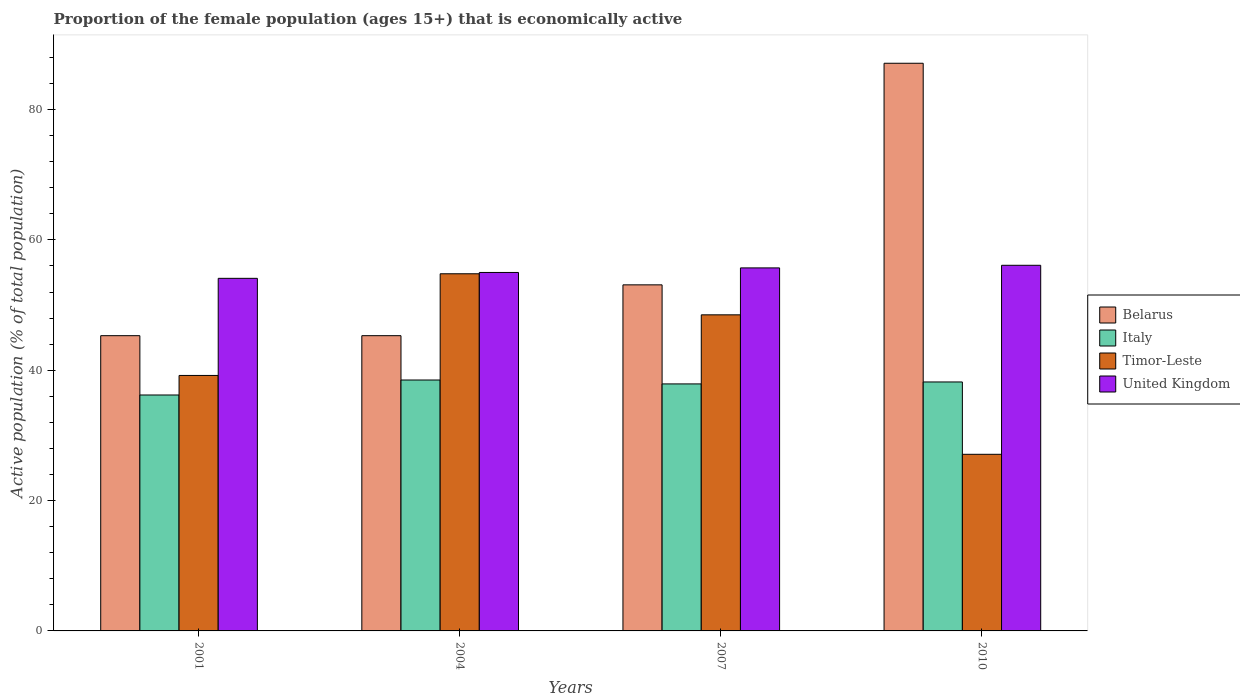Are the number of bars per tick equal to the number of legend labels?
Offer a terse response. Yes. Are the number of bars on each tick of the X-axis equal?
Your answer should be compact. Yes. How many bars are there on the 4th tick from the right?
Your answer should be compact. 4. What is the label of the 2nd group of bars from the left?
Your response must be concise. 2004. In how many cases, is the number of bars for a given year not equal to the number of legend labels?
Ensure brevity in your answer.  0. What is the proportion of the female population that is economically active in Italy in 2004?
Give a very brief answer. 38.5. Across all years, what is the maximum proportion of the female population that is economically active in Timor-Leste?
Make the answer very short. 54.8. Across all years, what is the minimum proportion of the female population that is economically active in Timor-Leste?
Offer a terse response. 27.1. In which year was the proportion of the female population that is economically active in Timor-Leste minimum?
Your answer should be very brief. 2010. What is the total proportion of the female population that is economically active in Timor-Leste in the graph?
Offer a very short reply. 169.6. What is the difference between the proportion of the female population that is economically active in Belarus in 2001 and that in 2010?
Provide a succinct answer. -41.8. What is the difference between the proportion of the female population that is economically active in Timor-Leste in 2010 and the proportion of the female population that is economically active in Italy in 2001?
Offer a very short reply. -9.1. What is the average proportion of the female population that is economically active in Timor-Leste per year?
Offer a terse response. 42.4. In the year 2010, what is the difference between the proportion of the female population that is economically active in United Kingdom and proportion of the female population that is economically active in Italy?
Your answer should be very brief. 17.9. What is the ratio of the proportion of the female population that is economically active in Belarus in 2007 to that in 2010?
Offer a terse response. 0.61. Is the proportion of the female population that is economically active in United Kingdom in 2001 less than that in 2010?
Your answer should be compact. Yes. Is the difference between the proportion of the female population that is economically active in United Kingdom in 2001 and 2007 greater than the difference between the proportion of the female population that is economically active in Italy in 2001 and 2007?
Offer a very short reply. Yes. What is the difference between the highest and the second highest proportion of the female population that is economically active in Timor-Leste?
Offer a terse response. 6.3. What is the difference between the highest and the lowest proportion of the female population that is economically active in United Kingdom?
Provide a short and direct response. 2. In how many years, is the proportion of the female population that is economically active in United Kingdom greater than the average proportion of the female population that is economically active in United Kingdom taken over all years?
Your response must be concise. 2. Is it the case that in every year, the sum of the proportion of the female population that is economically active in Italy and proportion of the female population that is economically active in United Kingdom is greater than the sum of proportion of the female population that is economically active in Belarus and proportion of the female population that is economically active in Timor-Leste?
Make the answer very short. Yes. What does the 4th bar from the left in 2010 represents?
Make the answer very short. United Kingdom. What does the 3rd bar from the right in 2010 represents?
Your answer should be compact. Italy. Is it the case that in every year, the sum of the proportion of the female population that is economically active in Timor-Leste and proportion of the female population that is economically active in Belarus is greater than the proportion of the female population that is economically active in Italy?
Provide a short and direct response. Yes. How many bars are there?
Keep it short and to the point. 16. Are all the bars in the graph horizontal?
Your answer should be compact. No. How many years are there in the graph?
Provide a short and direct response. 4. Are the values on the major ticks of Y-axis written in scientific E-notation?
Your response must be concise. No. How many legend labels are there?
Provide a succinct answer. 4. How are the legend labels stacked?
Make the answer very short. Vertical. What is the title of the graph?
Your response must be concise. Proportion of the female population (ages 15+) that is economically active. What is the label or title of the X-axis?
Provide a short and direct response. Years. What is the label or title of the Y-axis?
Provide a short and direct response. Active population (% of total population). What is the Active population (% of total population) in Belarus in 2001?
Offer a very short reply. 45.3. What is the Active population (% of total population) of Italy in 2001?
Make the answer very short. 36.2. What is the Active population (% of total population) of Timor-Leste in 2001?
Offer a terse response. 39.2. What is the Active population (% of total population) of United Kingdom in 2001?
Your answer should be compact. 54.1. What is the Active population (% of total population) in Belarus in 2004?
Offer a terse response. 45.3. What is the Active population (% of total population) in Italy in 2004?
Offer a terse response. 38.5. What is the Active population (% of total population) of Timor-Leste in 2004?
Keep it short and to the point. 54.8. What is the Active population (% of total population) in United Kingdom in 2004?
Offer a very short reply. 55. What is the Active population (% of total population) in Belarus in 2007?
Your response must be concise. 53.1. What is the Active population (% of total population) of Italy in 2007?
Provide a short and direct response. 37.9. What is the Active population (% of total population) of Timor-Leste in 2007?
Your answer should be compact. 48.5. What is the Active population (% of total population) of United Kingdom in 2007?
Keep it short and to the point. 55.7. What is the Active population (% of total population) of Belarus in 2010?
Provide a short and direct response. 87.1. What is the Active population (% of total population) in Italy in 2010?
Your answer should be compact. 38.2. What is the Active population (% of total population) of Timor-Leste in 2010?
Ensure brevity in your answer.  27.1. What is the Active population (% of total population) of United Kingdom in 2010?
Your answer should be compact. 56.1. Across all years, what is the maximum Active population (% of total population) of Belarus?
Ensure brevity in your answer.  87.1. Across all years, what is the maximum Active population (% of total population) of Italy?
Your response must be concise. 38.5. Across all years, what is the maximum Active population (% of total population) in Timor-Leste?
Make the answer very short. 54.8. Across all years, what is the maximum Active population (% of total population) in United Kingdom?
Your answer should be compact. 56.1. Across all years, what is the minimum Active population (% of total population) of Belarus?
Your answer should be compact. 45.3. Across all years, what is the minimum Active population (% of total population) in Italy?
Give a very brief answer. 36.2. Across all years, what is the minimum Active population (% of total population) of Timor-Leste?
Your response must be concise. 27.1. Across all years, what is the minimum Active population (% of total population) of United Kingdom?
Provide a short and direct response. 54.1. What is the total Active population (% of total population) of Belarus in the graph?
Offer a very short reply. 230.8. What is the total Active population (% of total population) of Italy in the graph?
Give a very brief answer. 150.8. What is the total Active population (% of total population) of Timor-Leste in the graph?
Make the answer very short. 169.6. What is the total Active population (% of total population) in United Kingdom in the graph?
Your response must be concise. 220.9. What is the difference between the Active population (% of total population) in Timor-Leste in 2001 and that in 2004?
Provide a short and direct response. -15.6. What is the difference between the Active population (% of total population) of Belarus in 2001 and that in 2007?
Offer a terse response. -7.8. What is the difference between the Active population (% of total population) of Belarus in 2001 and that in 2010?
Your answer should be compact. -41.8. What is the difference between the Active population (% of total population) of Timor-Leste in 2001 and that in 2010?
Provide a short and direct response. 12.1. What is the difference between the Active population (% of total population) of United Kingdom in 2001 and that in 2010?
Make the answer very short. -2. What is the difference between the Active population (% of total population) in Italy in 2004 and that in 2007?
Your response must be concise. 0.6. What is the difference between the Active population (% of total population) in Timor-Leste in 2004 and that in 2007?
Your answer should be very brief. 6.3. What is the difference between the Active population (% of total population) in Belarus in 2004 and that in 2010?
Offer a terse response. -41.8. What is the difference between the Active population (% of total population) of Timor-Leste in 2004 and that in 2010?
Ensure brevity in your answer.  27.7. What is the difference between the Active population (% of total population) in United Kingdom in 2004 and that in 2010?
Ensure brevity in your answer.  -1.1. What is the difference between the Active population (% of total population) of Belarus in 2007 and that in 2010?
Your response must be concise. -34. What is the difference between the Active population (% of total population) in Timor-Leste in 2007 and that in 2010?
Offer a very short reply. 21.4. What is the difference between the Active population (% of total population) of Belarus in 2001 and the Active population (% of total population) of Italy in 2004?
Make the answer very short. 6.8. What is the difference between the Active population (% of total population) in Italy in 2001 and the Active population (% of total population) in Timor-Leste in 2004?
Keep it short and to the point. -18.6. What is the difference between the Active population (% of total population) of Italy in 2001 and the Active population (% of total population) of United Kingdom in 2004?
Give a very brief answer. -18.8. What is the difference between the Active population (% of total population) of Timor-Leste in 2001 and the Active population (% of total population) of United Kingdom in 2004?
Your answer should be compact. -15.8. What is the difference between the Active population (% of total population) in Belarus in 2001 and the Active population (% of total population) in Italy in 2007?
Make the answer very short. 7.4. What is the difference between the Active population (% of total population) of Belarus in 2001 and the Active population (% of total population) of Timor-Leste in 2007?
Provide a succinct answer. -3.2. What is the difference between the Active population (% of total population) of Italy in 2001 and the Active population (% of total population) of Timor-Leste in 2007?
Provide a short and direct response. -12.3. What is the difference between the Active population (% of total population) in Italy in 2001 and the Active population (% of total population) in United Kingdom in 2007?
Provide a short and direct response. -19.5. What is the difference between the Active population (% of total population) of Timor-Leste in 2001 and the Active population (% of total population) of United Kingdom in 2007?
Keep it short and to the point. -16.5. What is the difference between the Active population (% of total population) of Belarus in 2001 and the Active population (% of total population) of Italy in 2010?
Provide a succinct answer. 7.1. What is the difference between the Active population (% of total population) of Belarus in 2001 and the Active population (% of total population) of Timor-Leste in 2010?
Provide a succinct answer. 18.2. What is the difference between the Active population (% of total population) of Belarus in 2001 and the Active population (% of total population) of United Kingdom in 2010?
Keep it short and to the point. -10.8. What is the difference between the Active population (% of total population) of Italy in 2001 and the Active population (% of total population) of Timor-Leste in 2010?
Provide a short and direct response. 9.1. What is the difference between the Active population (% of total population) in Italy in 2001 and the Active population (% of total population) in United Kingdom in 2010?
Keep it short and to the point. -19.9. What is the difference between the Active population (% of total population) of Timor-Leste in 2001 and the Active population (% of total population) of United Kingdom in 2010?
Your answer should be compact. -16.9. What is the difference between the Active population (% of total population) of Belarus in 2004 and the Active population (% of total population) of Italy in 2007?
Offer a terse response. 7.4. What is the difference between the Active population (% of total population) of Belarus in 2004 and the Active population (% of total population) of Timor-Leste in 2007?
Make the answer very short. -3.2. What is the difference between the Active population (% of total population) in Italy in 2004 and the Active population (% of total population) in United Kingdom in 2007?
Offer a very short reply. -17.2. What is the difference between the Active population (% of total population) of Belarus in 2004 and the Active population (% of total population) of Italy in 2010?
Offer a very short reply. 7.1. What is the difference between the Active population (% of total population) in Belarus in 2004 and the Active population (% of total population) in Timor-Leste in 2010?
Give a very brief answer. 18.2. What is the difference between the Active population (% of total population) of Italy in 2004 and the Active population (% of total population) of Timor-Leste in 2010?
Make the answer very short. 11.4. What is the difference between the Active population (% of total population) of Italy in 2004 and the Active population (% of total population) of United Kingdom in 2010?
Provide a short and direct response. -17.6. What is the difference between the Active population (% of total population) of Timor-Leste in 2004 and the Active population (% of total population) of United Kingdom in 2010?
Give a very brief answer. -1.3. What is the difference between the Active population (% of total population) of Italy in 2007 and the Active population (% of total population) of Timor-Leste in 2010?
Your response must be concise. 10.8. What is the difference between the Active population (% of total population) of Italy in 2007 and the Active population (% of total population) of United Kingdom in 2010?
Provide a short and direct response. -18.2. What is the average Active population (% of total population) of Belarus per year?
Ensure brevity in your answer.  57.7. What is the average Active population (% of total population) of Italy per year?
Your answer should be compact. 37.7. What is the average Active population (% of total population) in Timor-Leste per year?
Provide a short and direct response. 42.4. What is the average Active population (% of total population) of United Kingdom per year?
Provide a short and direct response. 55.23. In the year 2001, what is the difference between the Active population (% of total population) in Belarus and Active population (% of total population) in Timor-Leste?
Offer a terse response. 6.1. In the year 2001, what is the difference between the Active population (% of total population) of Italy and Active population (% of total population) of United Kingdom?
Keep it short and to the point. -17.9. In the year 2001, what is the difference between the Active population (% of total population) of Timor-Leste and Active population (% of total population) of United Kingdom?
Offer a very short reply. -14.9. In the year 2004, what is the difference between the Active population (% of total population) in Italy and Active population (% of total population) in Timor-Leste?
Your answer should be compact. -16.3. In the year 2004, what is the difference between the Active population (% of total population) in Italy and Active population (% of total population) in United Kingdom?
Make the answer very short. -16.5. In the year 2004, what is the difference between the Active population (% of total population) of Timor-Leste and Active population (% of total population) of United Kingdom?
Your response must be concise. -0.2. In the year 2007, what is the difference between the Active population (% of total population) in Belarus and Active population (% of total population) in Timor-Leste?
Keep it short and to the point. 4.6. In the year 2007, what is the difference between the Active population (% of total population) of Italy and Active population (% of total population) of Timor-Leste?
Your answer should be compact. -10.6. In the year 2007, what is the difference between the Active population (% of total population) in Italy and Active population (% of total population) in United Kingdom?
Your response must be concise. -17.8. In the year 2010, what is the difference between the Active population (% of total population) of Belarus and Active population (% of total population) of Italy?
Offer a very short reply. 48.9. In the year 2010, what is the difference between the Active population (% of total population) of Belarus and Active population (% of total population) of Timor-Leste?
Your answer should be compact. 60. In the year 2010, what is the difference between the Active population (% of total population) of Italy and Active population (% of total population) of Timor-Leste?
Provide a succinct answer. 11.1. In the year 2010, what is the difference between the Active population (% of total population) in Italy and Active population (% of total population) in United Kingdom?
Make the answer very short. -17.9. In the year 2010, what is the difference between the Active population (% of total population) in Timor-Leste and Active population (% of total population) in United Kingdom?
Your answer should be very brief. -29. What is the ratio of the Active population (% of total population) in Italy in 2001 to that in 2004?
Provide a succinct answer. 0.94. What is the ratio of the Active population (% of total population) in Timor-Leste in 2001 to that in 2004?
Offer a very short reply. 0.72. What is the ratio of the Active population (% of total population) in United Kingdom in 2001 to that in 2004?
Offer a very short reply. 0.98. What is the ratio of the Active population (% of total population) in Belarus in 2001 to that in 2007?
Ensure brevity in your answer.  0.85. What is the ratio of the Active population (% of total population) of Italy in 2001 to that in 2007?
Offer a terse response. 0.96. What is the ratio of the Active population (% of total population) of Timor-Leste in 2001 to that in 2007?
Your answer should be very brief. 0.81. What is the ratio of the Active population (% of total population) in United Kingdom in 2001 to that in 2007?
Offer a very short reply. 0.97. What is the ratio of the Active population (% of total population) of Belarus in 2001 to that in 2010?
Provide a short and direct response. 0.52. What is the ratio of the Active population (% of total population) of Italy in 2001 to that in 2010?
Make the answer very short. 0.95. What is the ratio of the Active population (% of total population) in Timor-Leste in 2001 to that in 2010?
Your answer should be very brief. 1.45. What is the ratio of the Active population (% of total population) of Belarus in 2004 to that in 2007?
Your answer should be compact. 0.85. What is the ratio of the Active population (% of total population) of Italy in 2004 to that in 2007?
Make the answer very short. 1.02. What is the ratio of the Active population (% of total population) of Timor-Leste in 2004 to that in 2007?
Your response must be concise. 1.13. What is the ratio of the Active population (% of total population) of United Kingdom in 2004 to that in 2007?
Your answer should be compact. 0.99. What is the ratio of the Active population (% of total population) of Belarus in 2004 to that in 2010?
Your answer should be very brief. 0.52. What is the ratio of the Active population (% of total population) in Italy in 2004 to that in 2010?
Make the answer very short. 1.01. What is the ratio of the Active population (% of total population) in Timor-Leste in 2004 to that in 2010?
Your answer should be compact. 2.02. What is the ratio of the Active population (% of total population) in United Kingdom in 2004 to that in 2010?
Give a very brief answer. 0.98. What is the ratio of the Active population (% of total population) of Belarus in 2007 to that in 2010?
Offer a very short reply. 0.61. What is the ratio of the Active population (% of total population) in Italy in 2007 to that in 2010?
Give a very brief answer. 0.99. What is the ratio of the Active population (% of total population) of Timor-Leste in 2007 to that in 2010?
Your answer should be very brief. 1.79. What is the difference between the highest and the second highest Active population (% of total population) of Belarus?
Give a very brief answer. 34. What is the difference between the highest and the second highest Active population (% of total population) in Italy?
Offer a terse response. 0.3. What is the difference between the highest and the lowest Active population (% of total population) of Belarus?
Your answer should be very brief. 41.8. What is the difference between the highest and the lowest Active population (% of total population) of Timor-Leste?
Provide a short and direct response. 27.7. 